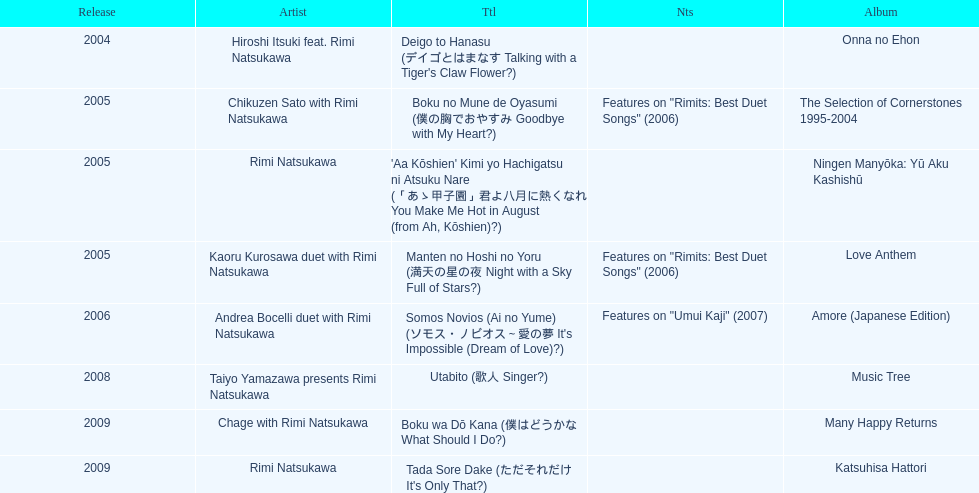How many other appearance did this artist make in 2005? 3. 